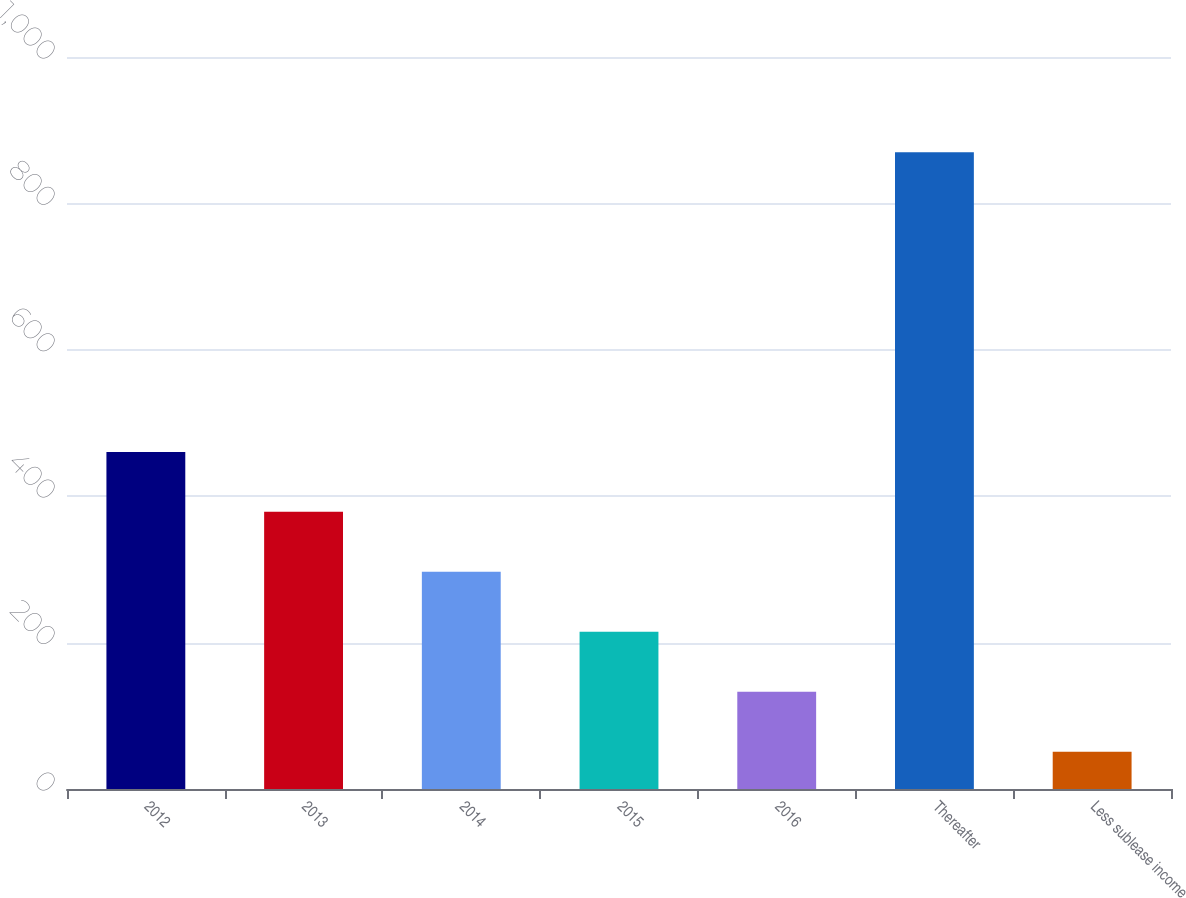<chart> <loc_0><loc_0><loc_500><loc_500><bar_chart><fcel>2012<fcel>2013<fcel>2014<fcel>2015<fcel>2016<fcel>Thereafter<fcel>Less sublease income<nl><fcel>460.5<fcel>378.6<fcel>296.7<fcel>214.8<fcel>132.9<fcel>870<fcel>51<nl></chart> 